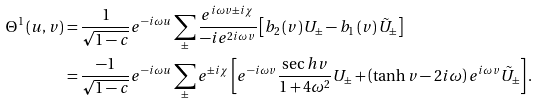Convert formula to latex. <formula><loc_0><loc_0><loc_500><loc_500>\Theta ^ { 1 } \left ( u , v \right ) & = \frac { 1 } { \sqrt { 1 - c } } e ^ { - i \omega u } \sum _ { \pm } \frac { e ^ { i \omega v \pm i \chi } } { - i e ^ { 2 i \omega v } } \left [ b _ { 2 } \left ( v \right ) U _ { \pm } - b _ { 1 } \left ( v \right ) \tilde { U } _ { \pm } \right ] \\ & = \frac { - 1 } { \sqrt { 1 - c } } e ^ { - i \omega u } \sum _ { \pm } e ^ { \pm i \chi } \left [ e ^ { - i \omega v } \frac { \sec h v } { 1 + 4 \omega ^ { 2 } } U _ { \pm } + \left ( \tanh v - 2 i \omega \right ) e ^ { i \omega v } \tilde { U } _ { \pm } \right ] .</formula> 